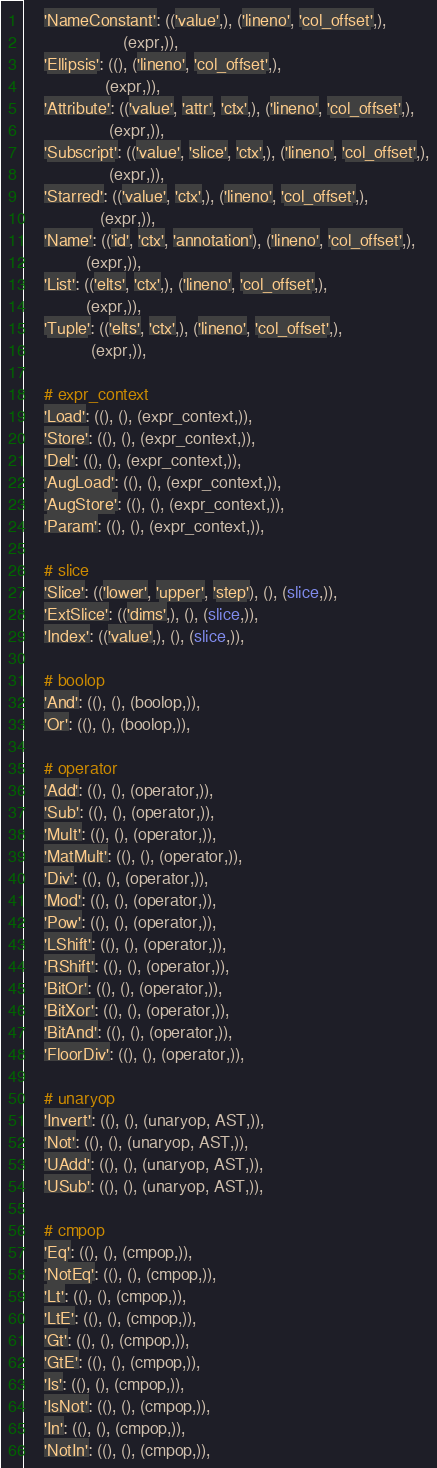<code> <loc_0><loc_0><loc_500><loc_500><_Python_>    'NameConstant': (('value',), ('lineno', 'col_offset',),
                     (expr,)),
    'Ellipsis': ((), ('lineno', 'col_offset',),
                 (expr,)),
    'Attribute': (('value', 'attr', 'ctx',), ('lineno', 'col_offset',),
                  (expr,)),
    'Subscript': (('value', 'slice', 'ctx',), ('lineno', 'col_offset',),
                  (expr,)),
    'Starred': (('value', 'ctx',), ('lineno', 'col_offset',),
                (expr,)),
    'Name': (('id', 'ctx', 'annotation'), ('lineno', 'col_offset',),
             (expr,)),
    'List': (('elts', 'ctx',), ('lineno', 'col_offset',),
             (expr,)),
    'Tuple': (('elts', 'ctx',), ('lineno', 'col_offset',),
              (expr,)),

    # expr_context
    'Load': ((), (), (expr_context,)),
    'Store': ((), (), (expr_context,)),
    'Del': ((), (), (expr_context,)),
    'AugLoad': ((), (), (expr_context,)),
    'AugStore': ((), (), (expr_context,)),
    'Param': ((), (), (expr_context,)),

    # slice
    'Slice': (('lower', 'upper', 'step'), (), (slice,)),
    'ExtSlice': (('dims',), (), (slice,)),
    'Index': (('value',), (), (slice,)),

    # boolop
    'And': ((), (), (boolop,)),
    'Or': ((), (), (boolop,)),

    # operator
    'Add': ((), (), (operator,)),
    'Sub': ((), (), (operator,)),
    'Mult': ((), (), (operator,)),
    'MatMult': ((), (), (operator,)),
    'Div': ((), (), (operator,)),
    'Mod': ((), (), (operator,)),
    'Pow': ((), (), (operator,)),
    'LShift': ((), (), (operator,)),
    'RShift': ((), (), (operator,)),
    'BitOr': ((), (), (operator,)),
    'BitXor': ((), (), (operator,)),
    'BitAnd': ((), (), (operator,)),
    'FloorDiv': ((), (), (operator,)),

    # unaryop
    'Invert': ((), (), (unaryop, AST,)),
    'Not': ((), (), (unaryop, AST,)),
    'UAdd': ((), (), (unaryop, AST,)),
    'USub': ((), (), (unaryop, AST,)),

    # cmpop
    'Eq': ((), (), (cmpop,)),
    'NotEq': ((), (), (cmpop,)),
    'Lt': ((), (), (cmpop,)),
    'LtE': ((), (), (cmpop,)),
    'Gt': ((), (), (cmpop,)),
    'GtE': ((), (), (cmpop,)),
    'Is': ((), (), (cmpop,)),
    'IsNot': ((), (), (cmpop,)),
    'In': ((), (), (cmpop,)),
    'NotIn': ((), (), (cmpop,)),
</code> 